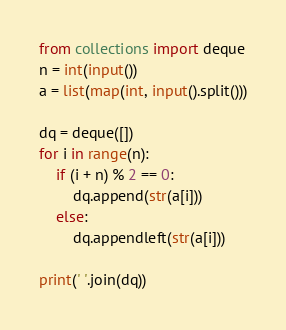Convert code to text. <code><loc_0><loc_0><loc_500><loc_500><_Python_>from collections import deque
n = int(input())
a = list(map(int, input().split()))

dq = deque([])
for i in range(n):
    if (i + n) % 2 == 0:
        dq.append(str(a[i]))
    else:
        dq.appendleft(str(a[i]))

print(' '.join(dq))
</code> 